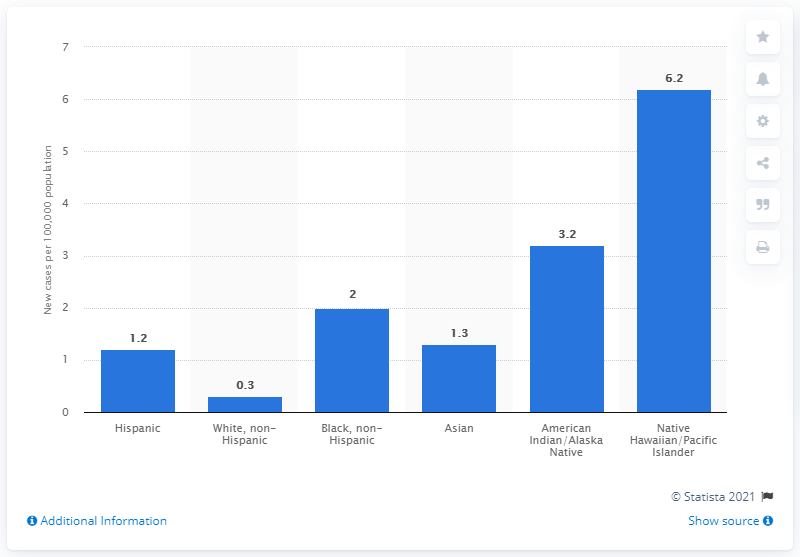List a handful of essential elements in this visual. There were approximately 1,200 new cases of TB in the Hispanic population in 2020. 